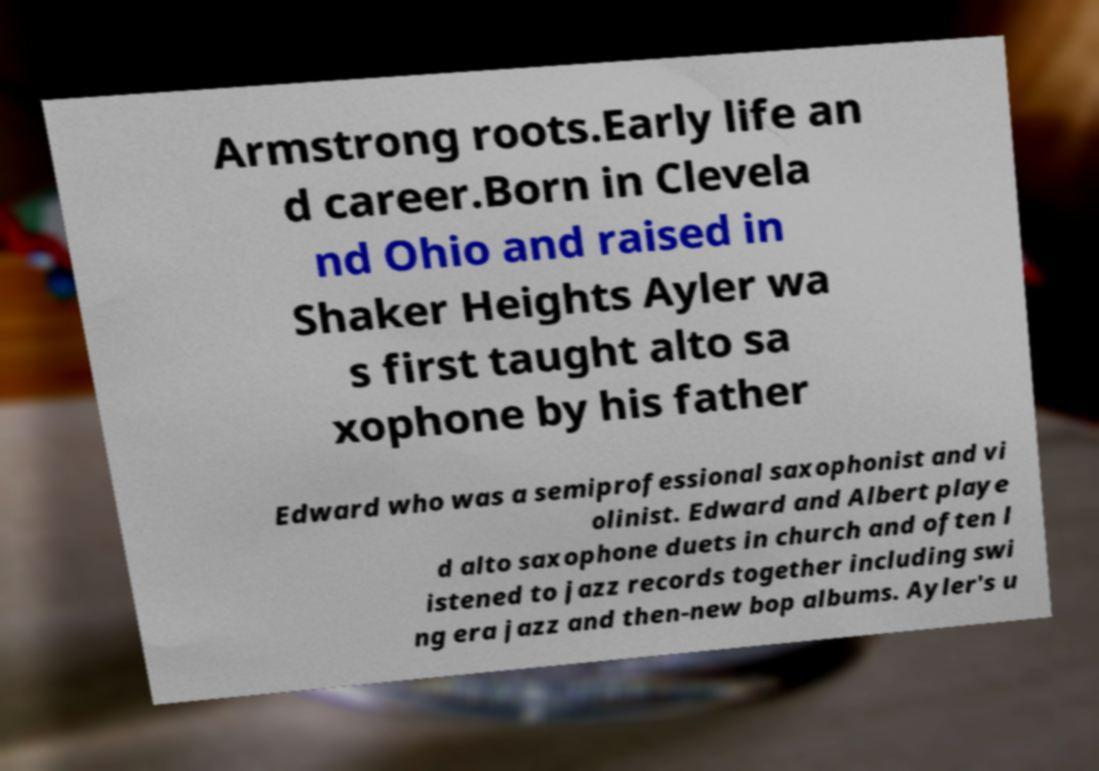Can you accurately transcribe the text from the provided image for me? Armstrong roots.Early life an d career.Born in Clevela nd Ohio and raised in Shaker Heights Ayler wa s first taught alto sa xophone by his father Edward who was a semiprofessional saxophonist and vi olinist. Edward and Albert playe d alto saxophone duets in church and often l istened to jazz records together including swi ng era jazz and then-new bop albums. Ayler's u 